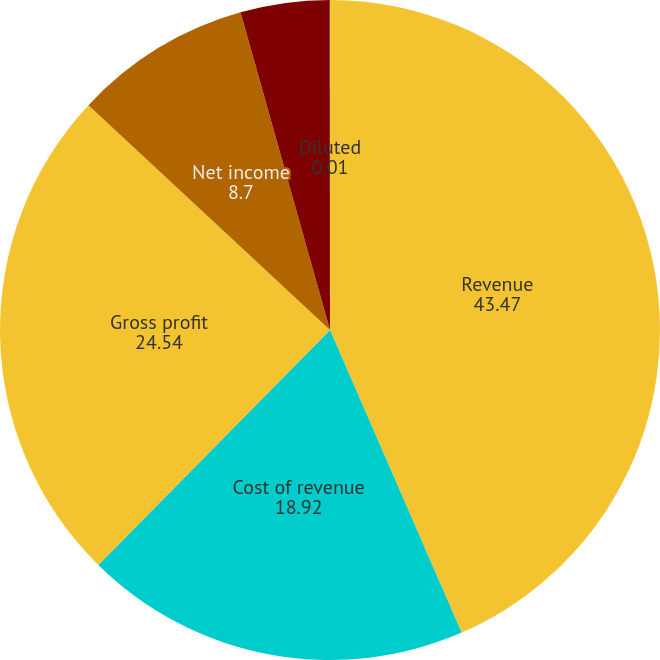Convert chart. <chart><loc_0><loc_0><loc_500><loc_500><pie_chart><fcel>Revenue<fcel>Cost of revenue<fcel>Gross profit<fcel>Net income<fcel>Basic<fcel>Diluted<nl><fcel>43.47%<fcel>18.92%<fcel>24.54%<fcel>8.7%<fcel>4.36%<fcel>0.01%<nl></chart> 